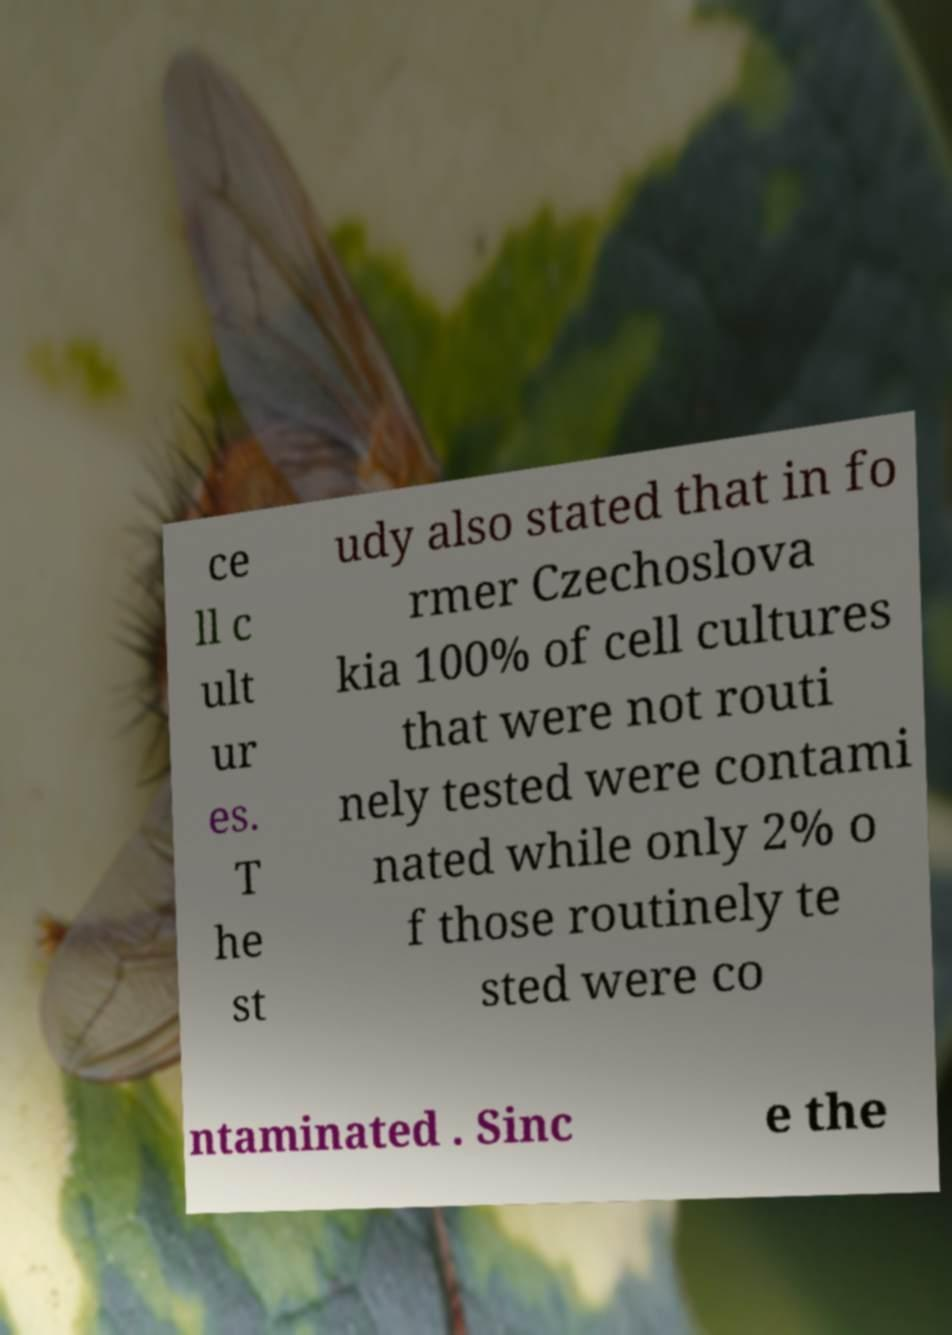Please identify and transcribe the text found in this image. ce ll c ult ur es. T he st udy also stated that in fo rmer Czechoslova kia 100% of cell cultures that were not routi nely tested were contami nated while only 2% o f those routinely te sted were co ntaminated . Sinc e the 